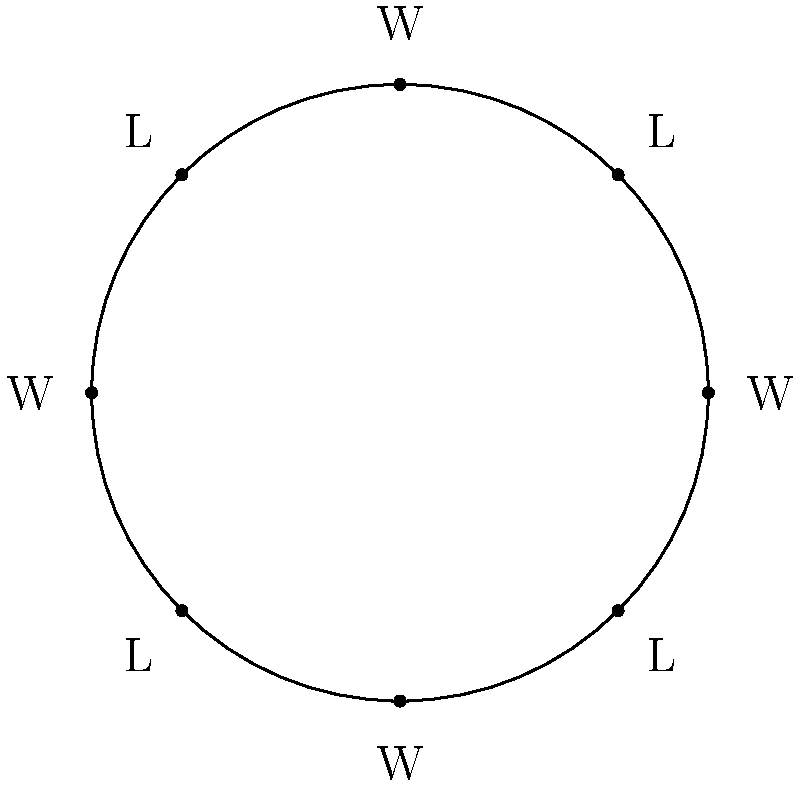Consider a circular graph representing a team's game outcomes, where 'W' denotes a win and 'L' a loss. The pattern repeats every 4 games (WLWL). If we model this as a cyclic group of order 8, what is the order of the element representing a single game outcome? To solve this problem, let's follow these steps:

1) First, we need to understand what the cyclic group represents:
   - Each element in the group represents a rotation of the circle.
   - The identity element (e) represents no rotation (or a full rotation).
   - The generator of the group represents a rotation by one position (one game).

2) The order of the group is 8, as there are 8 positions in the circle.

3) The pattern WLWL repeats every 4 games. This means that rotating the circle 4 times brings us back to the starting position.

4) In group theory, the order of an element is the smallest positive integer $n$ such that $a^n = e$, where $a$ is the element and $e$ is the identity.

5) In this case, we're looking for the order of a single game rotation (the generator of the group). Let's call this element $a$.

6) We can see that:
   $a^4 \neq e$ (4 rotations don't complete the circle)
   $a^8 = e$ (8 rotations complete the circle)

7) Therefore, the order of $a$ is 8.

This aligns with the fact that in a cyclic group of order $n$, the order of the generator is always $n$.
Answer: 8 